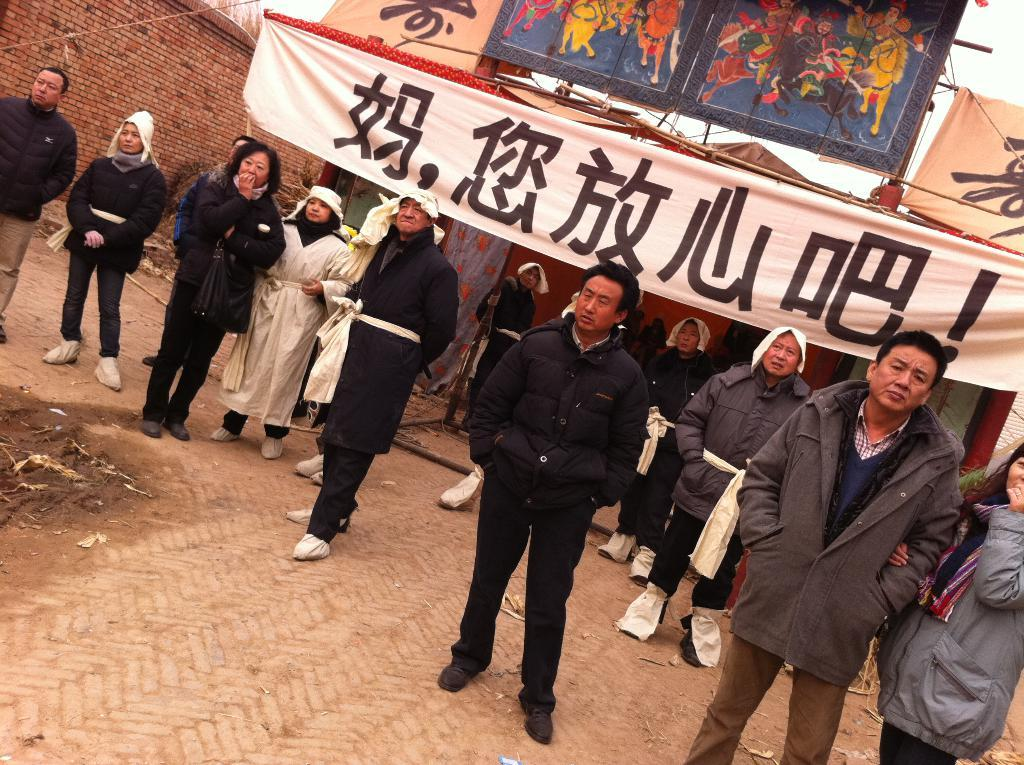How many people are in the image? There is a group of people in the image. What is the position of the people in the image? The people are standing on the ground. What can be seen in the background of the image? There is a banner and a brick wall in the background of the image. What is written on the banner? The banner has something written on it. What other objects can be seen in the background of the image? There are other objects visible in the background of the image. How many dogs are playing with a cast in the image? There are no dogs or casts present in the image. Can you see a card being held by one of the people in the image? There is no card visible in the image. 